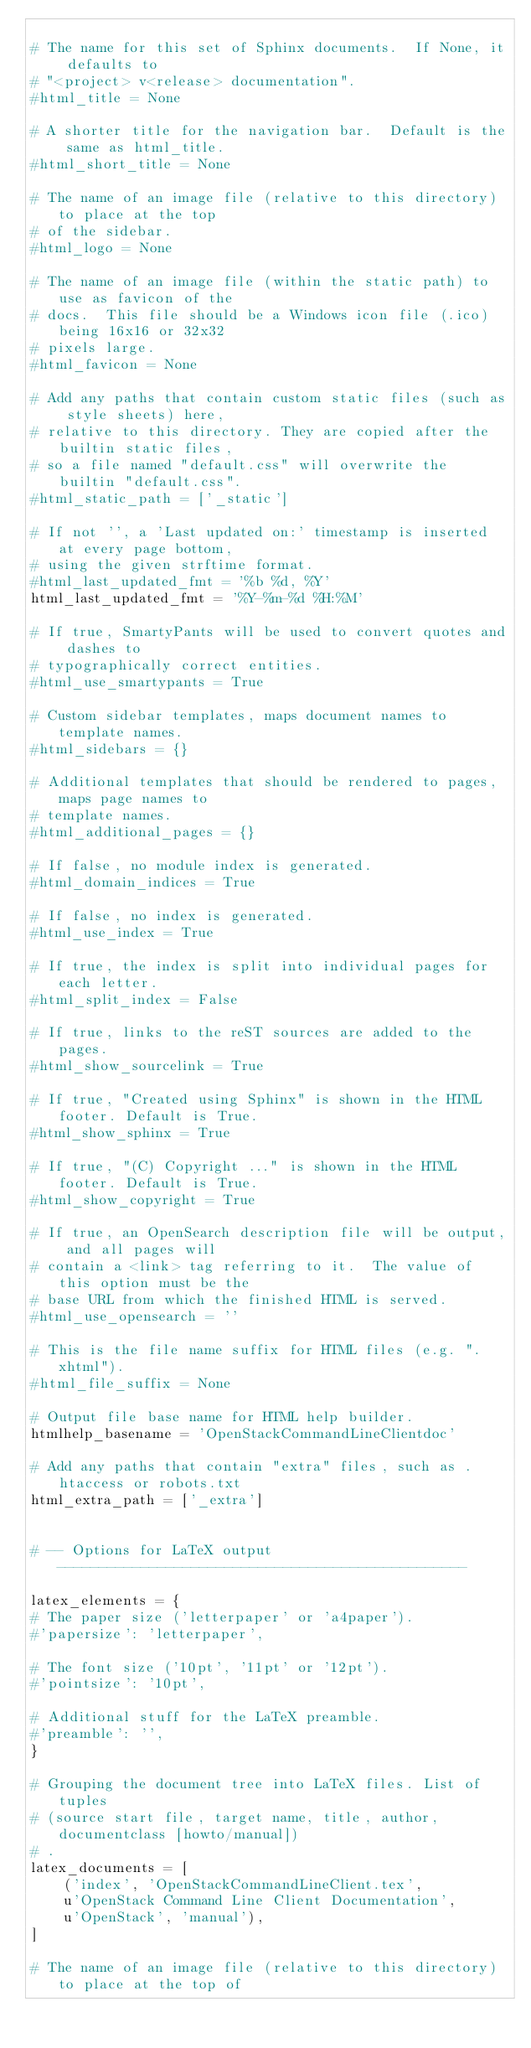<code> <loc_0><loc_0><loc_500><loc_500><_Python_>
# The name for this set of Sphinx documents.  If None, it defaults to
# "<project> v<release> documentation".
#html_title = None

# A shorter title for the navigation bar.  Default is the same as html_title.
#html_short_title = None

# The name of an image file (relative to this directory) to place at the top
# of the sidebar.
#html_logo = None

# The name of an image file (within the static path) to use as favicon of the
# docs.  This file should be a Windows icon file (.ico) being 16x16 or 32x32
# pixels large.
#html_favicon = None

# Add any paths that contain custom static files (such as style sheets) here,
# relative to this directory. They are copied after the builtin static files,
# so a file named "default.css" will overwrite the builtin "default.css".
#html_static_path = ['_static']

# If not '', a 'Last updated on:' timestamp is inserted at every page bottom,
# using the given strftime format.
#html_last_updated_fmt = '%b %d, %Y'
html_last_updated_fmt = '%Y-%m-%d %H:%M'

# If true, SmartyPants will be used to convert quotes and dashes to
# typographically correct entities.
#html_use_smartypants = True

# Custom sidebar templates, maps document names to template names.
#html_sidebars = {}

# Additional templates that should be rendered to pages, maps page names to
# template names.
#html_additional_pages = {}

# If false, no module index is generated.
#html_domain_indices = True

# If false, no index is generated.
#html_use_index = True

# If true, the index is split into individual pages for each letter.
#html_split_index = False

# If true, links to the reST sources are added to the pages.
#html_show_sourcelink = True

# If true, "Created using Sphinx" is shown in the HTML footer. Default is True.
#html_show_sphinx = True

# If true, "(C) Copyright ..." is shown in the HTML footer. Default is True.
#html_show_copyright = True

# If true, an OpenSearch description file will be output, and all pages will
# contain a <link> tag referring to it.  The value of this option must be the
# base URL from which the finished HTML is served.
#html_use_opensearch = ''

# This is the file name suffix for HTML files (e.g. ".xhtml").
#html_file_suffix = None

# Output file base name for HTML help builder.
htmlhelp_basename = 'OpenStackCommandLineClientdoc'

# Add any paths that contain "extra" files, such as .htaccess or robots.txt
html_extra_path = ['_extra']


# -- Options for LaTeX output -------------------------------------------------

latex_elements = {
# The paper size ('letterpaper' or 'a4paper').
#'papersize': 'letterpaper',

# The font size ('10pt', '11pt' or '12pt').
#'pointsize': '10pt',

# Additional stuff for the LaTeX preamble.
#'preamble': '',
}

# Grouping the document tree into LaTeX files. List of tuples
# (source start file, target name, title, author, documentclass [howto/manual])
# .
latex_documents = [
    ('index', 'OpenStackCommandLineClient.tex',
    u'OpenStack Command Line Client Documentation',
    u'OpenStack', 'manual'),
]

# The name of an image file (relative to this directory) to place at the top of</code> 